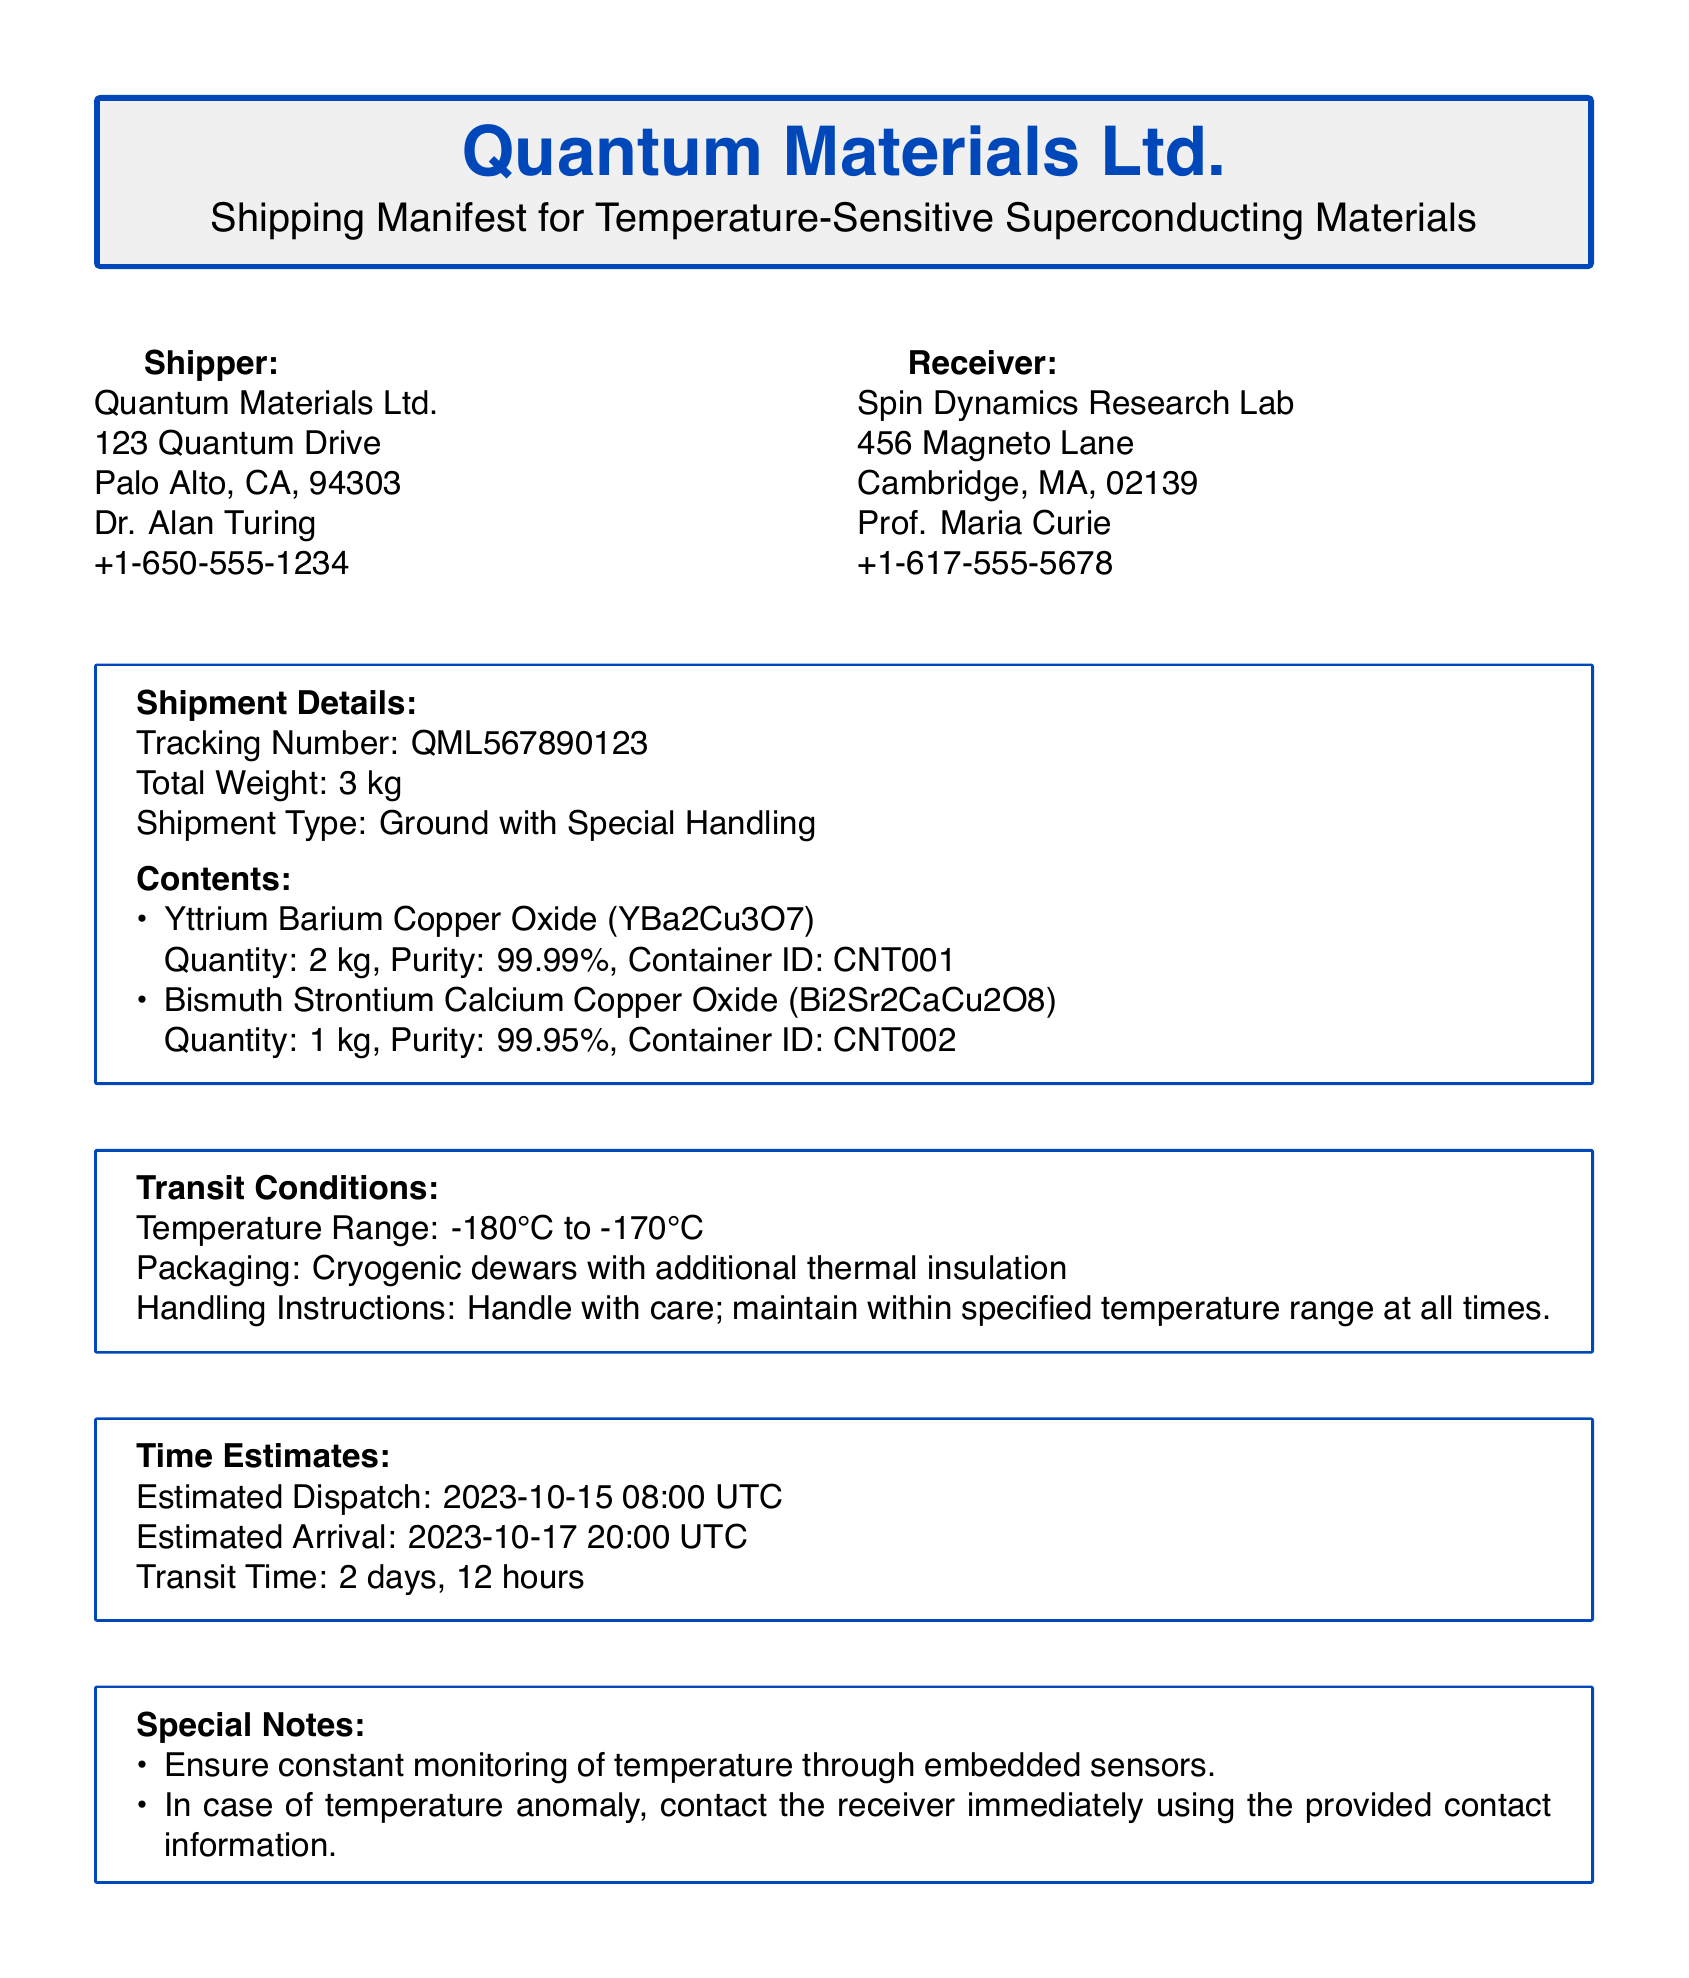what is the shipper's name? The shipper's name is listed at the top of the document under the Shipper section.
Answer: Quantum Materials Ltd what is the receiver's address? The receiver's address can be found in the Receiver section of the document.
Answer: 456 Magneto Lane, Cambridge, MA, 02139 what is the total weight of the shipment? The total weight is specified in the Shipment Details section.
Answer: 3 kg what is the tracking number? The tracking number is provided in the Shipment Details section.
Answer: QML567890123 what is the temperature range for transit? The temperature range is specified in the Transit Conditions section of the document.
Answer: -180°C to -170°C how many kilograms of Yttrium Barium Copper Oxide are being shipped? This information is detailed in the Contents section, listing the quantities of materials.
Answer: 2 kg what is the estimated arrival date? The estimated arrival date is found in the Time Estimates section.
Answer: 2023-10-17 what are the handling instructions for the shipment? Handling instructions are provided in the Transit Conditions section.
Answer: Handle with care; maintain within specified temperature range at all times what special monitoring should be done during transit? This information is included in the Special Notes section.
Answer: Ensure constant monitoring of temperature through embedded sensors 